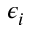<formula> <loc_0><loc_0><loc_500><loc_500>\epsilon _ { i }</formula> 